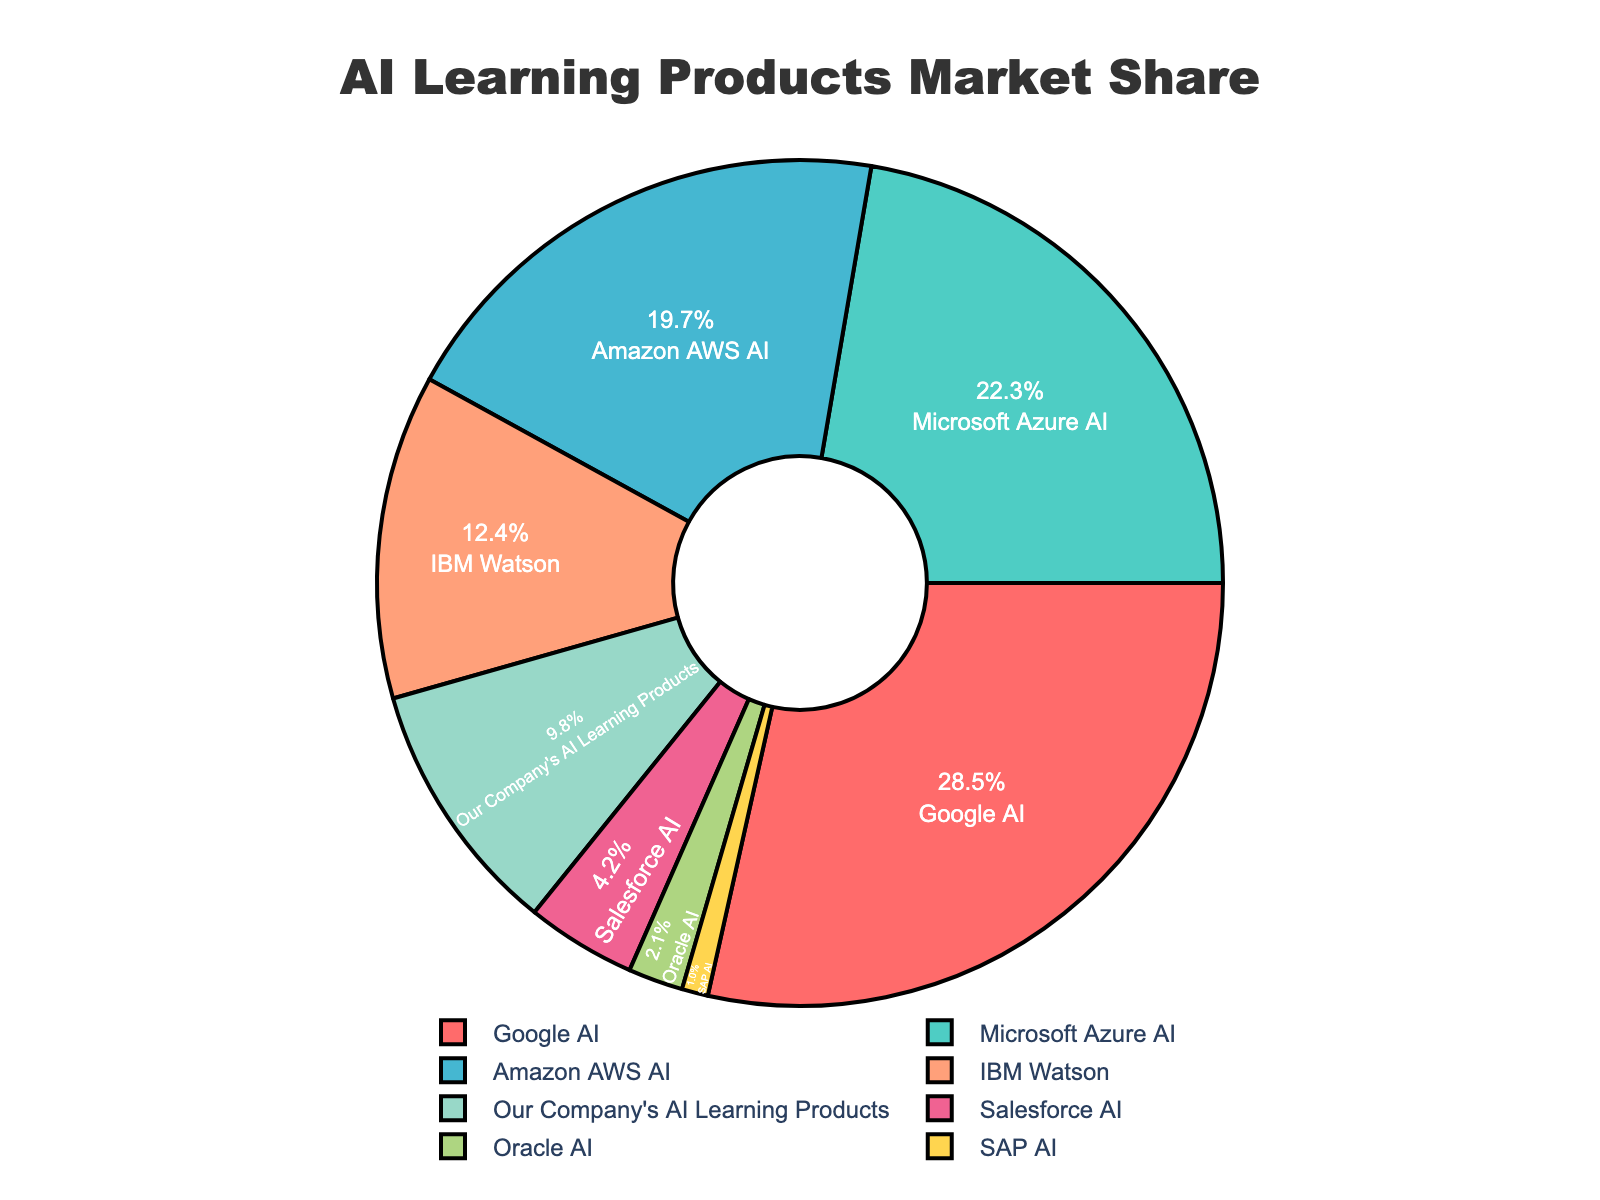Which AI learning product has the highest market share? Looking at the chart, the segment labeled "Google AI" is the largest slice, covering 28.5% of the entire pie.
Answer: Google AI What is the combined market share of Amazon AWS AI and IBM Watson? To find the combined market share, add the percentages of Amazon AWS AI and IBM Watson. Amazon AWS AI has 19.7% and IBM Watson has 12.4%. So, 19.7 + 12.4 = 32.1%.
Answer: 32.1% Which has a larger market share: Microsoft Azure AI or Our Company's AI Learning Products? The segment for Microsoft Azure AI is 22.3%, while our company's AI learning products cover 9.8%. Comparing these, Microsoft Azure AI has a larger share.
Answer: Microsoft Azure AI What is the difference in market share between Google AI and Salesforce AI? Subtract the market share of Salesforce AI from Google AI. So, 28.5% - 4.2% = 24.3%.
Answer: 24.3% Which segment is colored yellow? By observing the figure, the yellow-colored segment represents SAP AI.
Answer: SAP AI How much larger is the market share of Google AI compared to SAP AI? Subtract the market share of SAP AI from Google AI: 28.5% - 1.0% = 27.5%.
Answer: 27.5% What's the total market share of Oracle AI, SAP AI, and Salesforce AI combined? Add the market shares of Oracle AI, SAP AI, and Salesforce AI. So, 2.1% + 1.0% + 4.2% = 7.3%.
Answer: 7.3% Are there any AI learning products with less than 5% market share? List them. By examining the chart, segments representing Salesforce AI (4.2%), Oracle AI (2.1%), and SAP AI (1.0%) are all below 5%.
Answer: Salesforce AI, Oracle AI, and SAP AI Which company comes second in terms of market share and what is the percentage? Observing the chart, the segment labeled "Microsoft Azure AI" comes second with 22.3%.
Answer: Microsoft Azure AI with 22.3% 